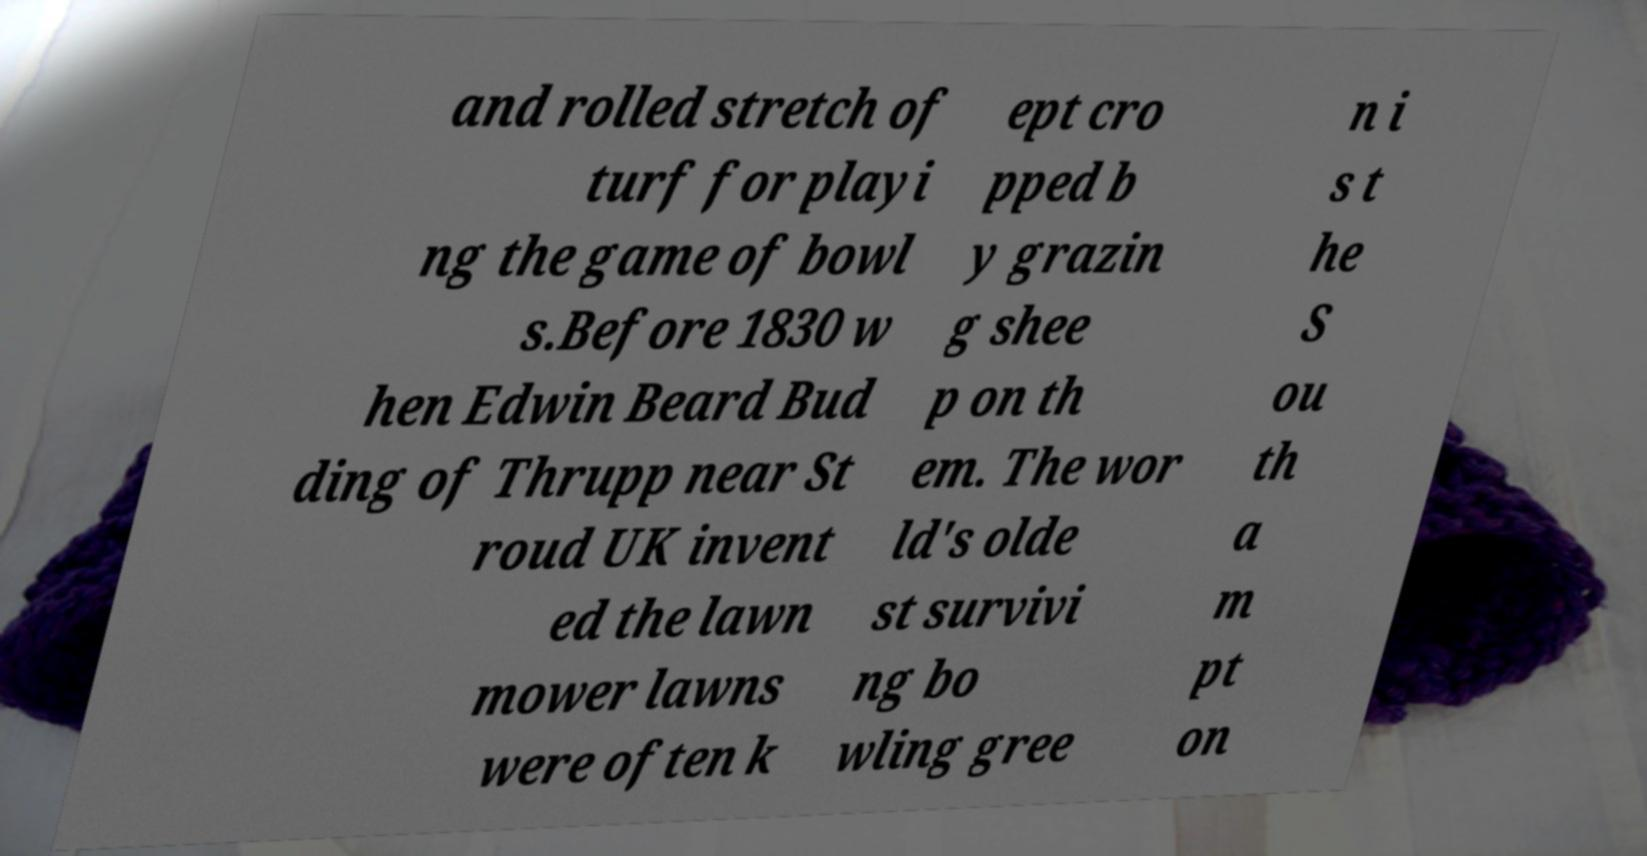Please read and relay the text visible in this image. What does it say? and rolled stretch of turf for playi ng the game of bowl s.Before 1830 w hen Edwin Beard Bud ding of Thrupp near St roud UK invent ed the lawn mower lawns were often k ept cro pped b y grazin g shee p on th em. The wor ld's olde st survivi ng bo wling gree n i s t he S ou th a m pt on 